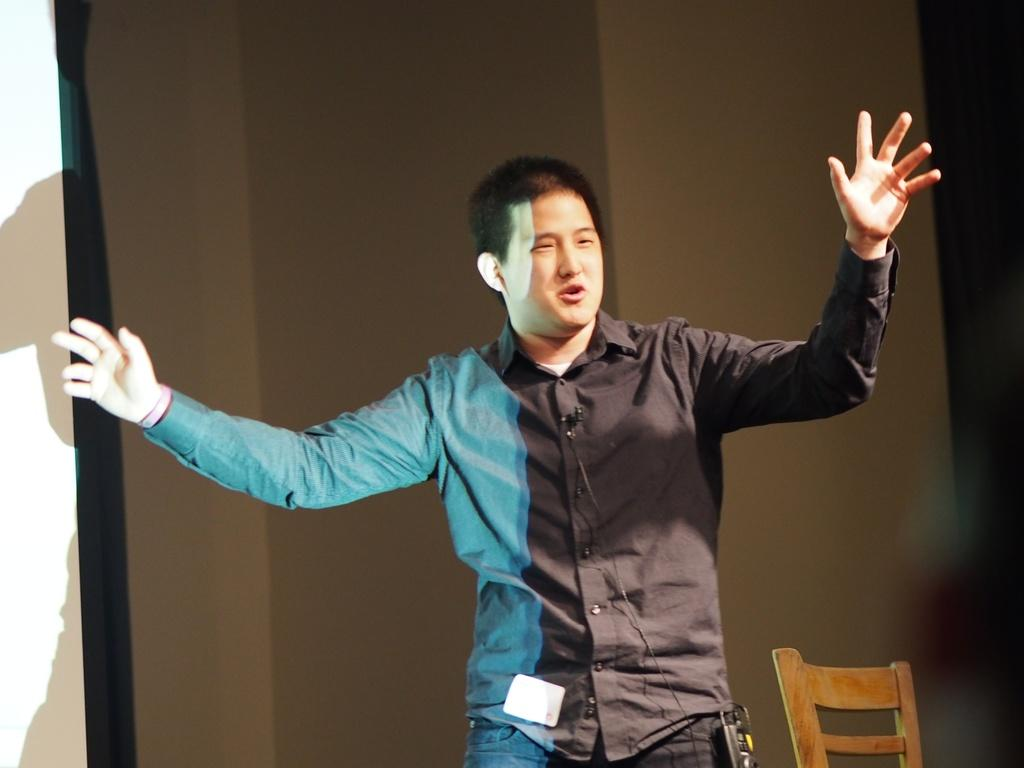What is the main subject of the image? There is a person standing in the center of the image. What object is located beside the person? There is a chair beside the person. What can be seen in the background of the image? There is a wall and a board in the background of the image. How many cans are visible in the image? There are no cans present in the image. What type of ticket can be seen in the person's hand in the image? There is no ticket visible in the person's hand in the image. 